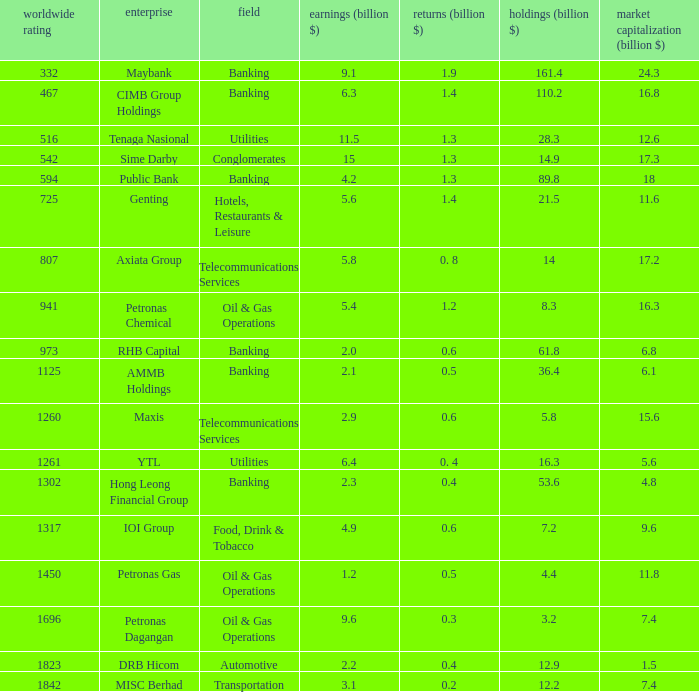8 0.5. 